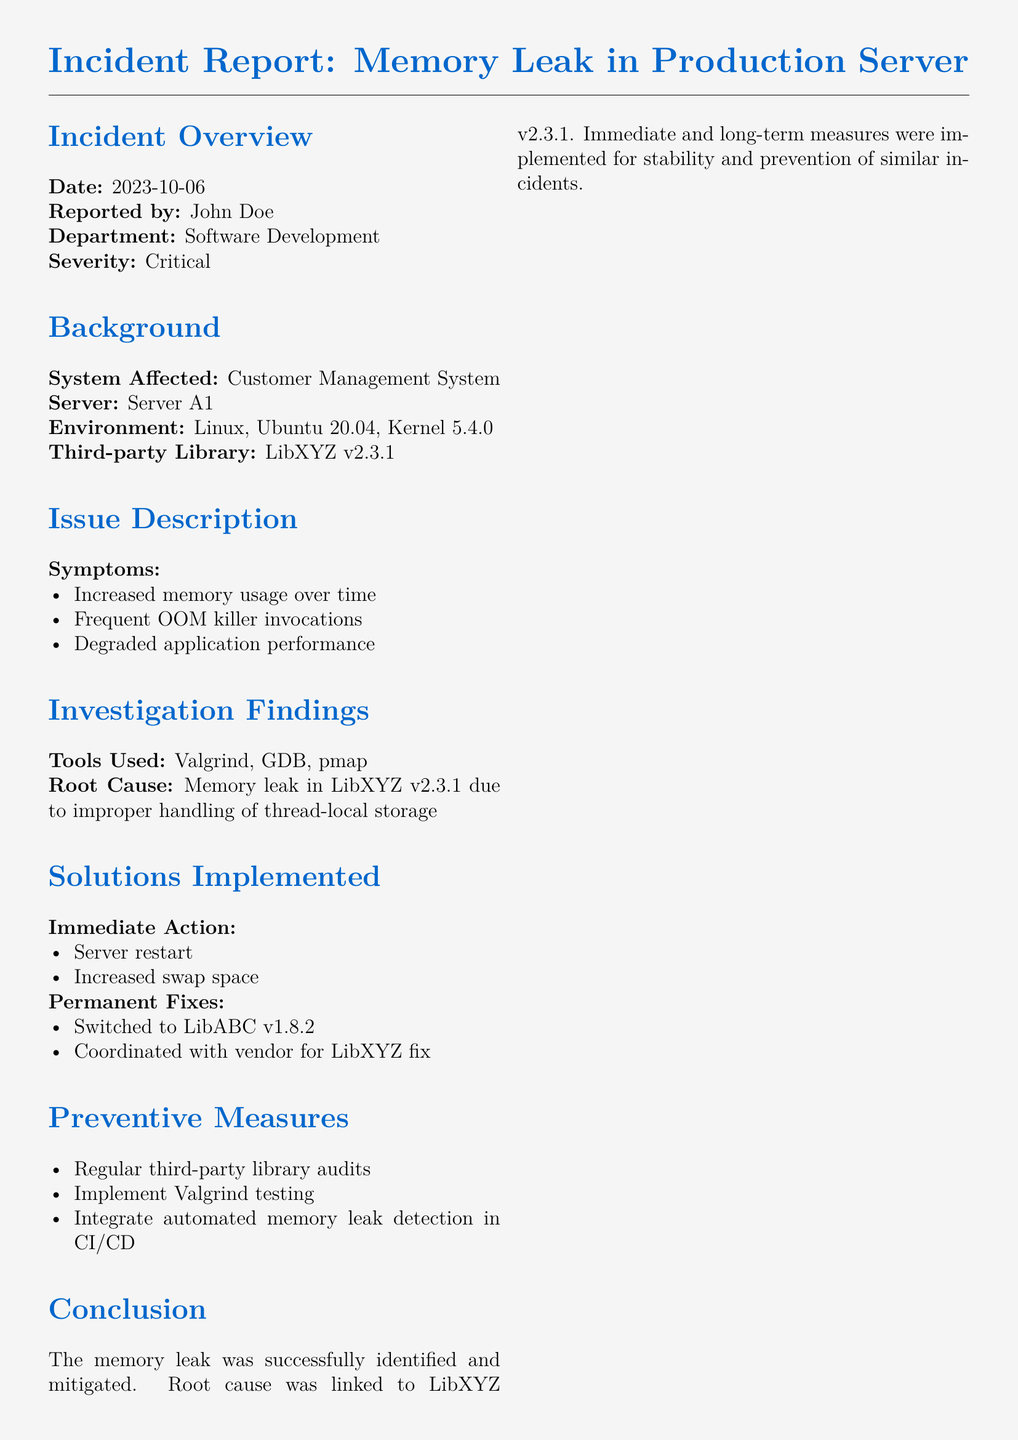What is the date of the incident? The date is provided in the incident overview section of the document.
Answer: 2023-10-06 Who reported the incident? The reported by section identifies the individual who reported the incident.
Answer: John Doe What is the affected system? The system affected is specified in the background section of the document.
Answer: Customer Management System What is the third-party library involved? The affected third-party library is mentioned in the background section.
Answer: LibXYZ v2.3.1 What was the root cause of the issue? The root cause is described in the investigation findings section, linking the issue to the third-party library.
Answer: Memory leak in LibXYZ v2.3.1 What tools were used for the investigation? The tools used are listed in the investigation findings section of the document.
Answer: Valgrind, GDB, pmap What was the immediate action taken? The immediate action section details actions taken to address the problem temporarily.
Answer: Server restart, Increased swap space Which library was switched to for a permanent fix? The permanent fixes section specifies the library that was chosen as an alternative.
Answer: LibABC v1.8.2 What preventive measures are suggested? The preventive measures listed provide guidance on avoiding future incidents.
Answer: Regular third-party library audits What is emphasized in the Linux Developer's Note? The Linux Developer's Note includes suggestions for software developers based on the incident.
Answer: Importance of rigorous testing and monitoring 